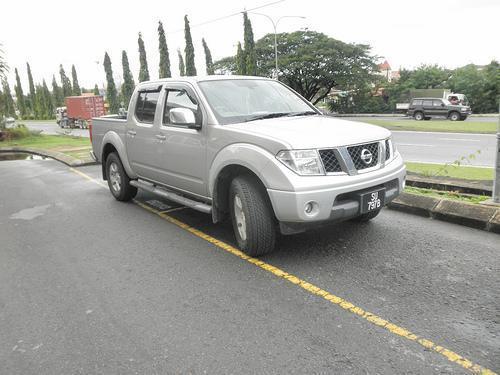How many trucks?
Give a very brief answer. 3. 